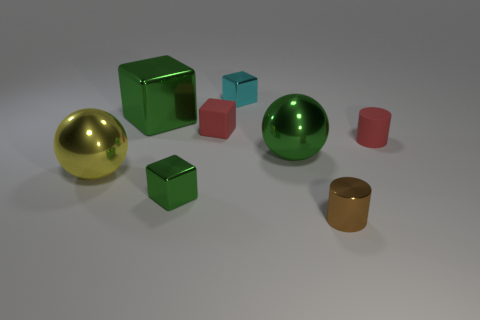What is the color of the matte cylinder?
Provide a short and direct response. Red. What is the red thing that is left of the tiny cyan metallic object made of?
Provide a short and direct response. Rubber. Do the tiny cyan object and the small red matte object that is left of the shiny cylinder have the same shape?
Provide a succinct answer. Yes. Are there more small green metal blocks than large green rubber cylinders?
Offer a very short reply. Yes. Is there any other thing that is the same color as the matte block?
Provide a succinct answer. Yes. What shape is the yellow thing that is the same material as the small cyan thing?
Offer a terse response. Sphere. There is a tiny thing that is to the left of the tiny matte thing that is on the left side of the brown cylinder; what is its material?
Provide a short and direct response. Metal. Is the shape of the red thing behind the small red matte cylinder the same as  the small cyan metal object?
Your response must be concise. Yes. Are there more small red cylinders in front of the tiny brown shiny cylinder than green metal cubes?
Ensure brevity in your answer.  No. Is there anything else that is made of the same material as the large yellow ball?
Provide a succinct answer. Yes. 